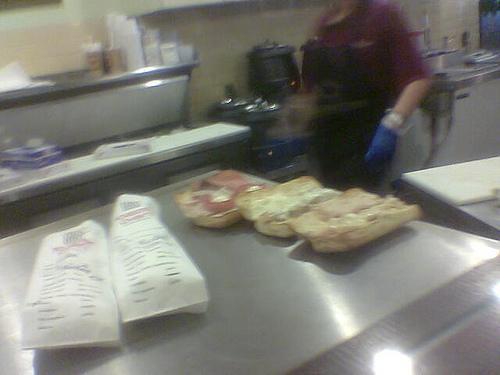Is this affirmation: "The hot dog is at the edge of the dining table." correct?
Answer yes or no. Yes. 